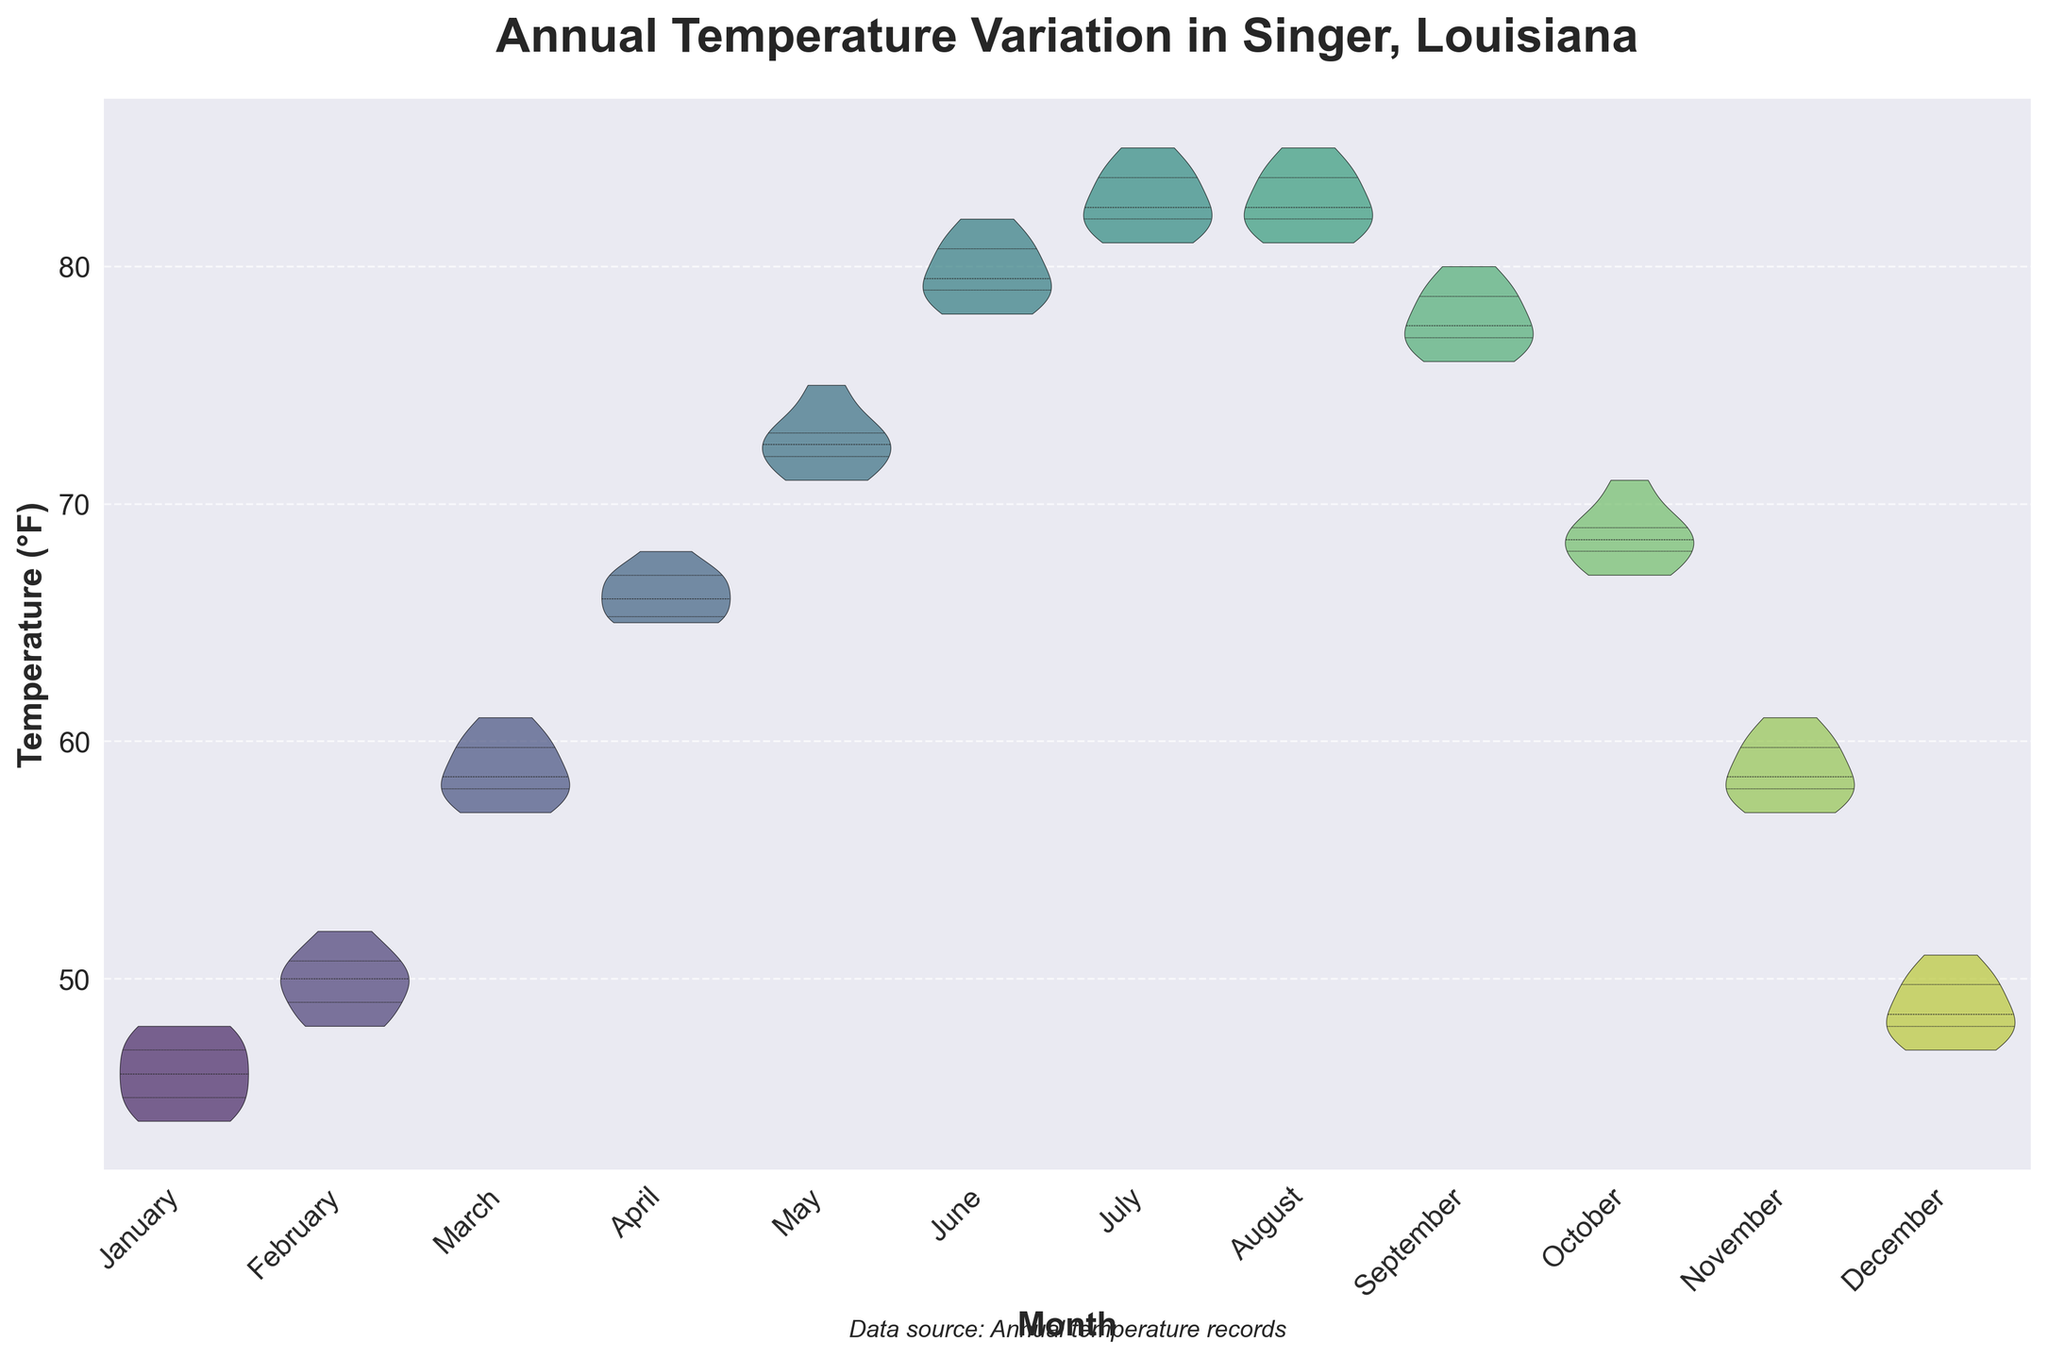What is the title of the figure? The title is written at the top of the figure in a larger and bold font. It provides a summary of what the figure represents.
Answer: Annual Temperature Variation in Singer, Louisiana What do the x-axis and y-axis represent? The x-axis represents the months of the year, labeled from January to December. The y-axis represents the temperature in degrees Fahrenheit (°F).
Answer: Months and Temperature (°F) Which month has the highest median temperature? The median temperature is indicated by the central line inside each violin plot. By looking at the middle values of each month's plot, the highest median can be observed.
Answer: July and August What is the overall temperature range for January? The temperature range can be identified by the overall span of the violin plot for January. The lowest point is around 44°F and the highest point is around 48°F.
Answer: 44°F to 48°F How does the temperature variation in July compare to January? Compare the width and distribution of the violin plots for July and January. July shows a wider and higher range centered around a higher median compared to January.
Answer: July has a higher and more varied temperature range During which month is the temperature variation the narrowest? The month with the narrowest spread in the violin plot indicates the least variation in temperature. By visually inspecting, January shows a relatively narrow spread.
Answer: January Which months exhibit a similar median temperature as August? August's median can be compared with other months by looking at the level of the central line inside each month's violin plot. July and August have similar medians.
Answer: July In which month is the quartile range the smallest, and what does this indicate? The smallest quartile range is indicated by the central box inside the violin plot that spans the 25th to 75th percentiles. January's narrow quartile range indicates less temperature variability.
Answer: January; Less variability What's the general trend of temperatures from January to June? By observing the progression of the violin plot medians from January to June, there's a clear increasing trend indicating rising temperatures.
Answer: Increasing trend Which month has the widest temperature distribution and what could this imply? The month with the widest violin plot indicates a large spread in temperature data, suggesting high variability. Both July and August have wide distributions.
Answer: July and August; High variability 